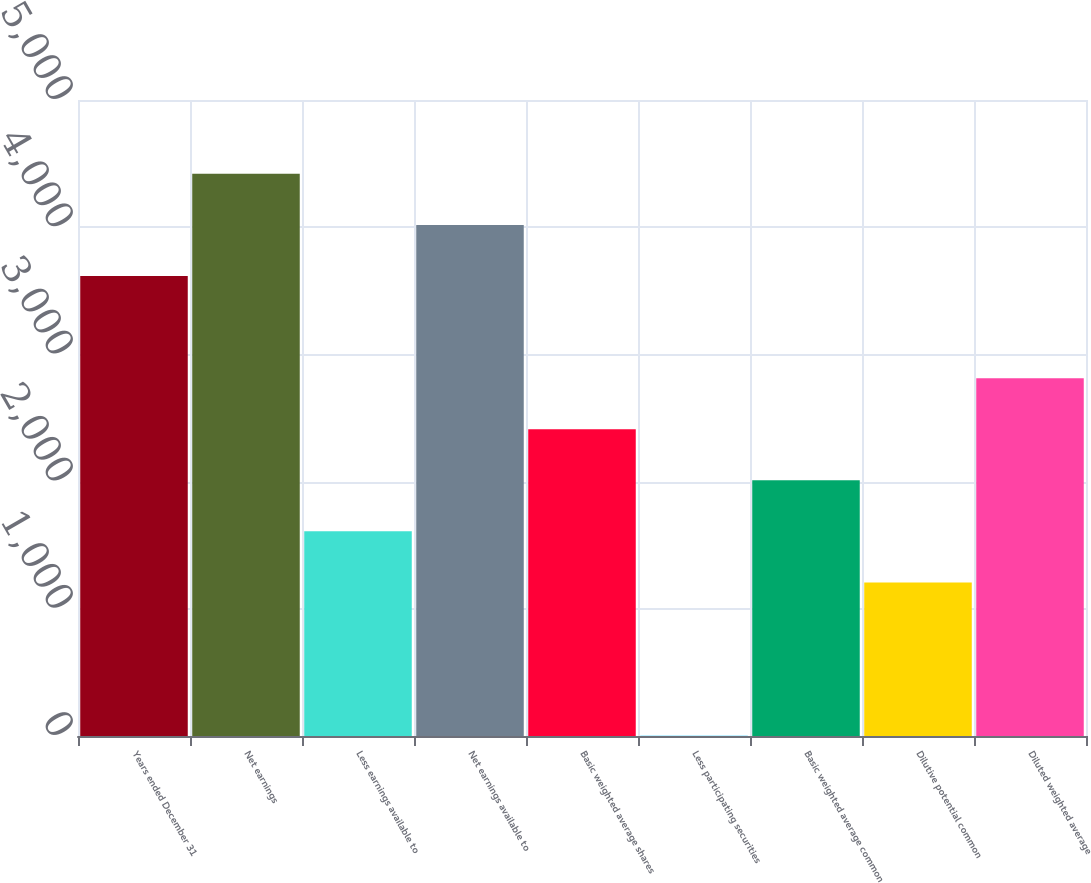Convert chart to OTSL. <chart><loc_0><loc_0><loc_500><loc_500><bar_chart><fcel>Years ended December 31<fcel>Net earnings<fcel>Less earnings available to<fcel>Net earnings available to<fcel>Basic weighted average shares<fcel>Less participating securities<fcel>Basic weighted average common<fcel>Dilutive potential common<fcel>Diluted weighted average<nl><fcel>3616.45<fcel>4419.55<fcel>1608.7<fcel>4018<fcel>2411.8<fcel>2.5<fcel>2010.25<fcel>1207.15<fcel>2813.35<nl></chart> 